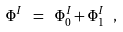<formula> <loc_0><loc_0><loc_500><loc_500>\Phi ^ { I } \ = \ \Phi ^ { I } _ { 0 } + \Phi ^ { I } _ { 1 } \ ,</formula> 